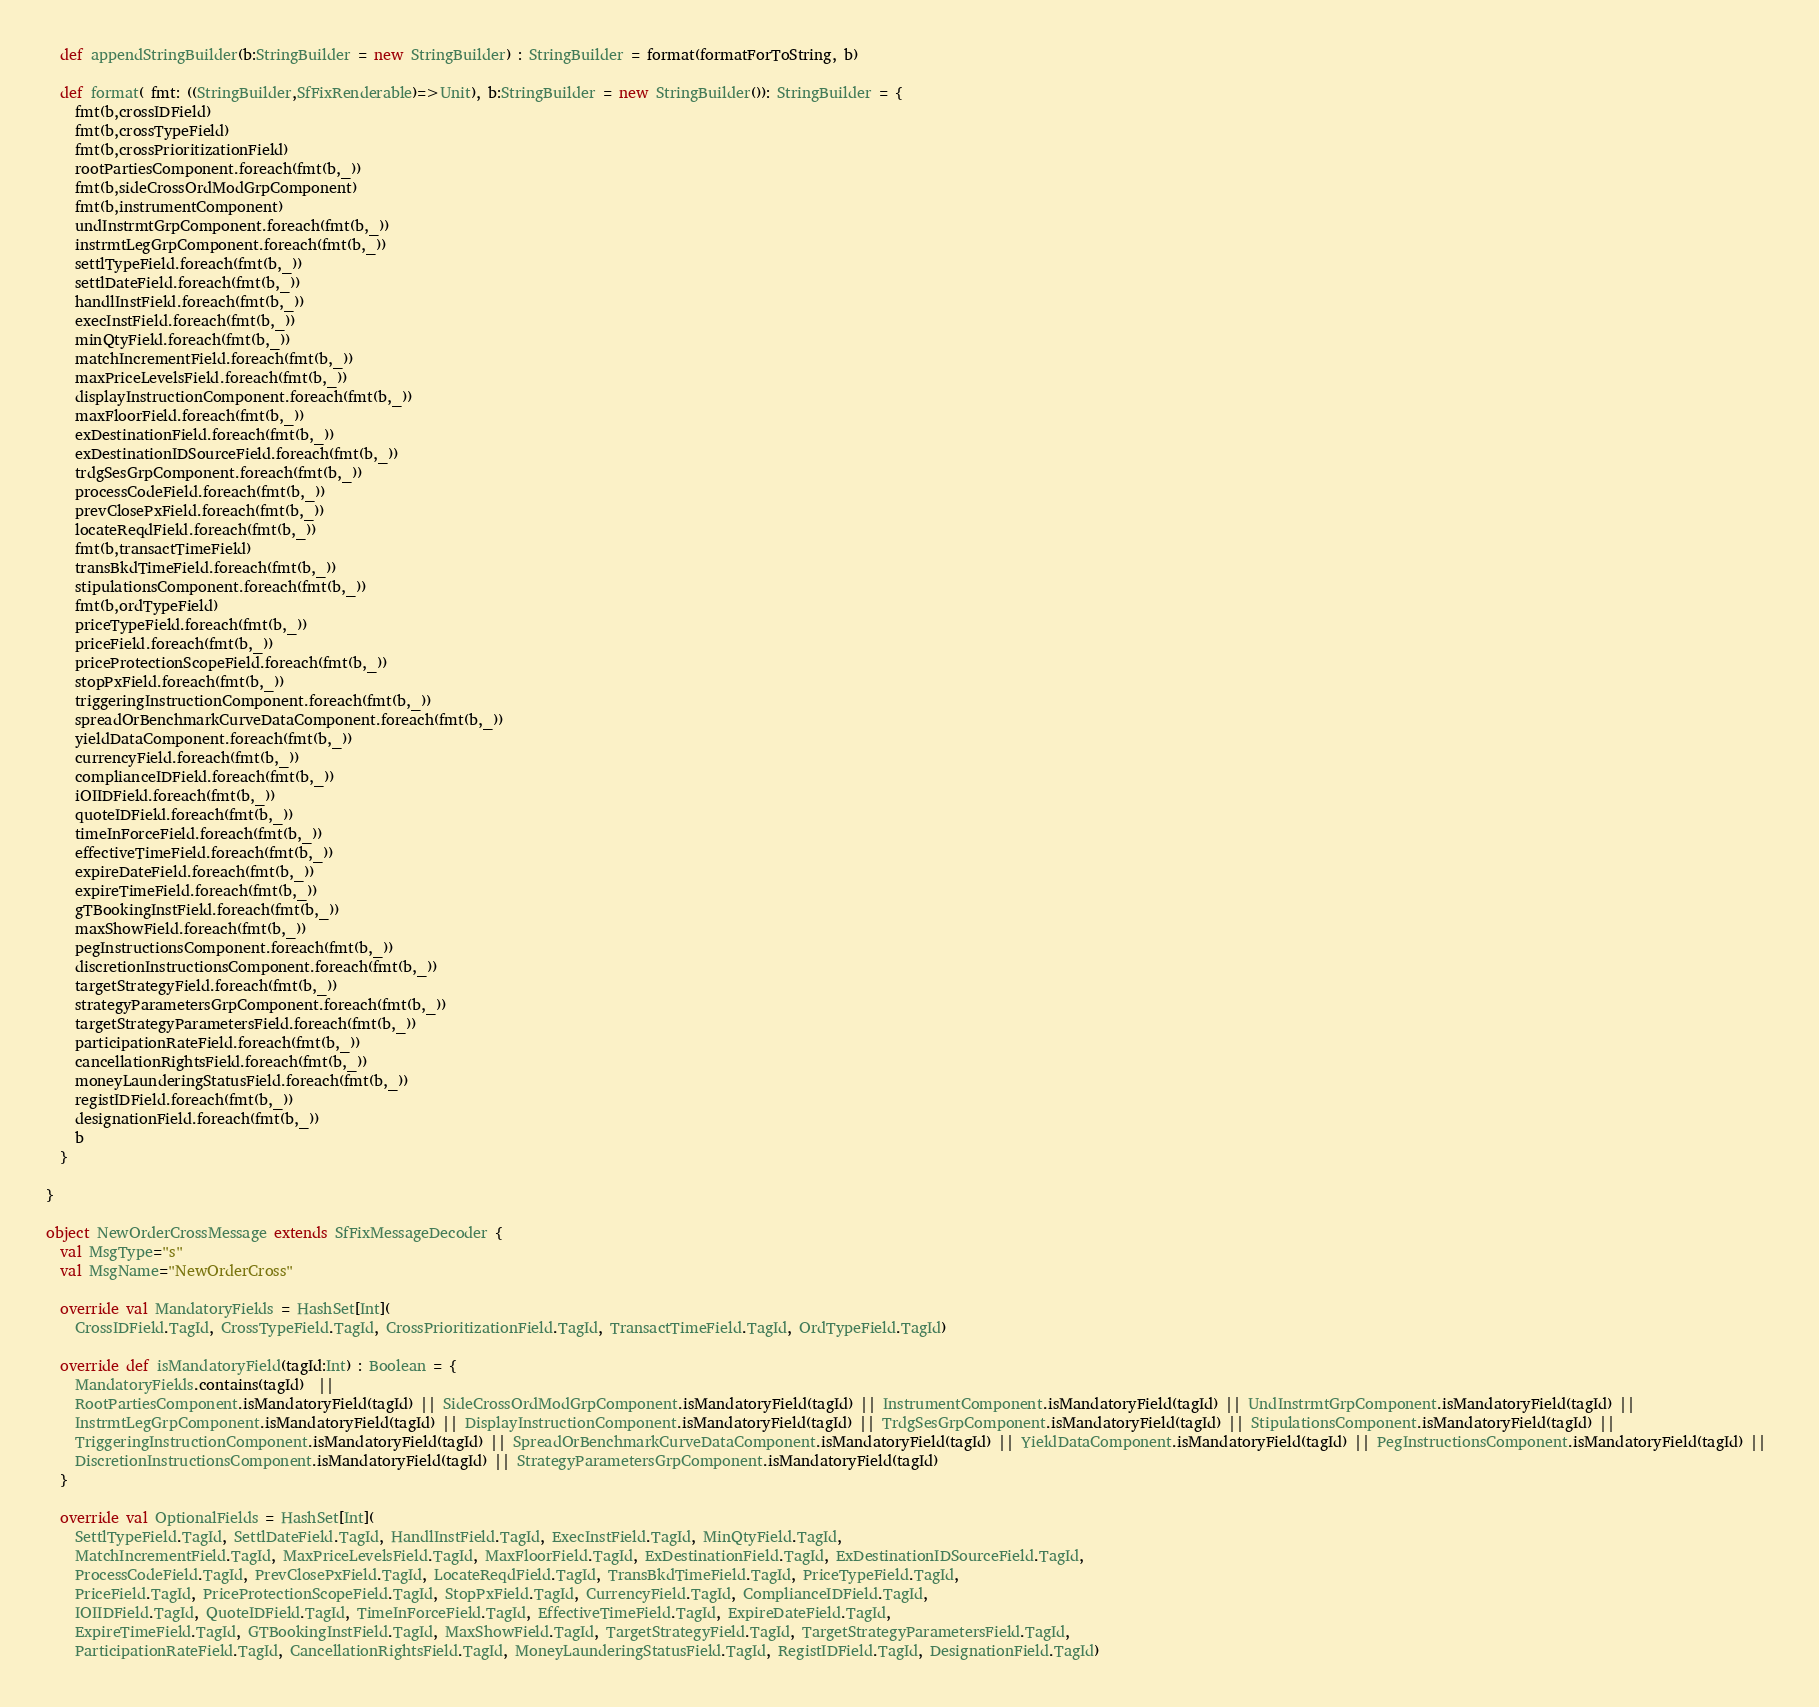Convert code to text. <code><loc_0><loc_0><loc_500><loc_500><_Scala_>  def appendStringBuilder(b:StringBuilder = new StringBuilder) : StringBuilder = format(formatForToString, b)

  def format( fmt: ((StringBuilder,SfFixRenderable)=>Unit), b:StringBuilder = new StringBuilder()): StringBuilder = {
    fmt(b,crossIDField)
    fmt(b,crossTypeField)
    fmt(b,crossPrioritizationField)
    rootPartiesComponent.foreach(fmt(b,_))
    fmt(b,sideCrossOrdModGrpComponent)
    fmt(b,instrumentComponent)
    undInstrmtGrpComponent.foreach(fmt(b,_))
    instrmtLegGrpComponent.foreach(fmt(b,_))
    settlTypeField.foreach(fmt(b,_))
    settlDateField.foreach(fmt(b,_))
    handlInstField.foreach(fmt(b,_))
    execInstField.foreach(fmt(b,_))
    minQtyField.foreach(fmt(b,_))
    matchIncrementField.foreach(fmt(b,_))
    maxPriceLevelsField.foreach(fmt(b,_))
    displayInstructionComponent.foreach(fmt(b,_))
    maxFloorField.foreach(fmt(b,_))
    exDestinationField.foreach(fmt(b,_))
    exDestinationIDSourceField.foreach(fmt(b,_))
    trdgSesGrpComponent.foreach(fmt(b,_))
    processCodeField.foreach(fmt(b,_))
    prevClosePxField.foreach(fmt(b,_))
    locateReqdField.foreach(fmt(b,_))
    fmt(b,transactTimeField)
    transBkdTimeField.foreach(fmt(b,_))
    stipulationsComponent.foreach(fmt(b,_))
    fmt(b,ordTypeField)
    priceTypeField.foreach(fmt(b,_))
    priceField.foreach(fmt(b,_))
    priceProtectionScopeField.foreach(fmt(b,_))
    stopPxField.foreach(fmt(b,_))
    triggeringInstructionComponent.foreach(fmt(b,_))
    spreadOrBenchmarkCurveDataComponent.foreach(fmt(b,_))
    yieldDataComponent.foreach(fmt(b,_))
    currencyField.foreach(fmt(b,_))
    complianceIDField.foreach(fmt(b,_))
    iOIIDField.foreach(fmt(b,_))
    quoteIDField.foreach(fmt(b,_))
    timeInForceField.foreach(fmt(b,_))
    effectiveTimeField.foreach(fmt(b,_))
    expireDateField.foreach(fmt(b,_))
    expireTimeField.foreach(fmt(b,_))
    gTBookingInstField.foreach(fmt(b,_))
    maxShowField.foreach(fmt(b,_))
    pegInstructionsComponent.foreach(fmt(b,_))
    discretionInstructionsComponent.foreach(fmt(b,_))
    targetStrategyField.foreach(fmt(b,_))
    strategyParametersGrpComponent.foreach(fmt(b,_))
    targetStrategyParametersField.foreach(fmt(b,_))
    participationRateField.foreach(fmt(b,_))
    cancellationRightsField.foreach(fmt(b,_))
    moneyLaunderingStatusField.foreach(fmt(b,_))
    registIDField.foreach(fmt(b,_))
    designationField.foreach(fmt(b,_))
    b
  }

}
     
object NewOrderCrossMessage extends SfFixMessageDecoder {
  val MsgType="s"
  val MsgName="NewOrderCross"
             
  override val MandatoryFields = HashSet[Int](
    CrossIDField.TagId, CrossTypeField.TagId, CrossPrioritizationField.TagId, TransactTimeField.TagId, OrdTypeField.TagId)

  override def isMandatoryField(tagId:Int) : Boolean = {
    MandatoryFields.contains(tagId)  || 
    RootPartiesComponent.isMandatoryField(tagId) || SideCrossOrdModGrpComponent.isMandatoryField(tagId) || InstrumentComponent.isMandatoryField(tagId) || UndInstrmtGrpComponent.isMandatoryField(tagId) || 
    InstrmtLegGrpComponent.isMandatoryField(tagId) || DisplayInstructionComponent.isMandatoryField(tagId) || TrdgSesGrpComponent.isMandatoryField(tagId) || StipulationsComponent.isMandatoryField(tagId) || 
    TriggeringInstructionComponent.isMandatoryField(tagId) || SpreadOrBenchmarkCurveDataComponent.isMandatoryField(tagId) || YieldDataComponent.isMandatoryField(tagId) || PegInstructionsComponent.isMandatoryField(tagId) || 
    DiscretionInstructionsComponent.isMandatoryField(tagId) || StrategyParametersGrpComponent.isMandatoryField(tagId)
  }

  override val OptionalFields = HashSet[Int](
    SettlTypeField.TagId, SettlDateField.TagId, HandlInstField.TagId, ExecInstField.TagId, MinQtyField.TagId, 
    MatchIncrementField.TagId, MaxPriceLevelsField.TagId, MaxFloorField.TagId, ExDestinationField.TagId, ExDestinationIDSourceField.TagId, 
    ProcessCodeField.TagId, PrevClosePxField.TagId, LocateReqdField.TagId, TransBkdTimeField.TagId, PriceTypeField.TagId, 
    PriceField.TagId, PriceProtectionScopeField.TagId, StopPxField.TagId, CurrencyField.TagId, ComplianceIDField.TagId, 
    IOIIDField.TagId, QuoteIDField.TagId, TimeInForceField.TagId, EffectiveTimeField.TagId, ExpireDateField.TagId, 
    ExpireTimeField.TagId, GTBookingInstField.TagId, MaxShowField.TagId, TargetStrategyField.TagId, TargetStrategyParametersField.TagId, 
    ParticipationRateField.TagId, CancellationRightsField.TagId, MoneyLaunderingStatusField.TagId, RegistIDField.TagId, DesignationField.TagId)
</code> 